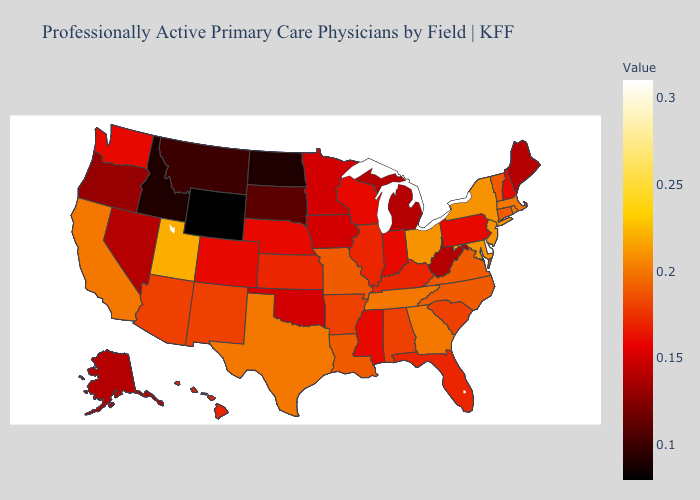Does Utah have the lowest value in the USA?
Concise answer only. No. Which states have the lowest value in the MidWest?
Answer briefly. North Dakota. Among the states that border Virginia , which have the lowest value?
Concise answer only. West Virginia. Does Missouri have the highest value in the USA?
Concise answer only. No. Among the states that border Wisconsin , which have the lowest value?
Keep it brief. Michigan. Which states have the lowest value in the South?
Give a very brief answer. West Virginia. Which states hav the highest value in the MidWest?
Write a very short answer. Ohio. 